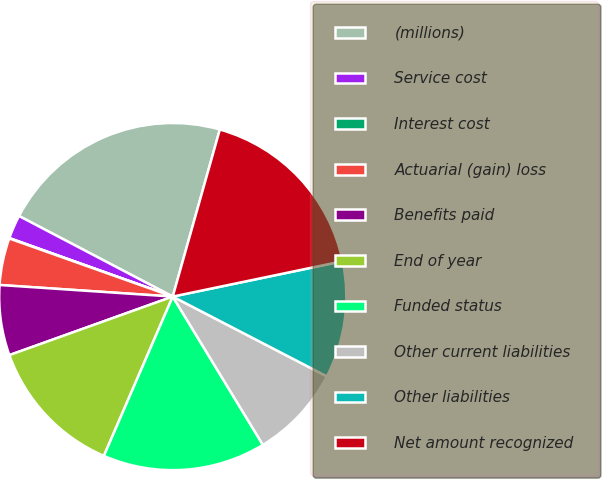Convert chart to OTSL. <chart><loc_0><loc_0><loc_500><loc_500><pie_chart><fcel>(millions)<fcel>Service cost<fcel>Interest cost<fcel>Actuarial (gain) loss<fcel>Benefits paid<fcel>End of year<fcel>Funded status<fcel>Other current liabilities<fcel>Other liabilities<fcel>Net amount recognized<nl><fcel>21.69%<fcel>2.21%<fcel>0.04%<fcel>4.37%<fcel>6.54%<fcel>13.03%<fcel>15.19%<fcel>8.7%<fcel>10.87%<fcel>17.36%<nl></chart> 